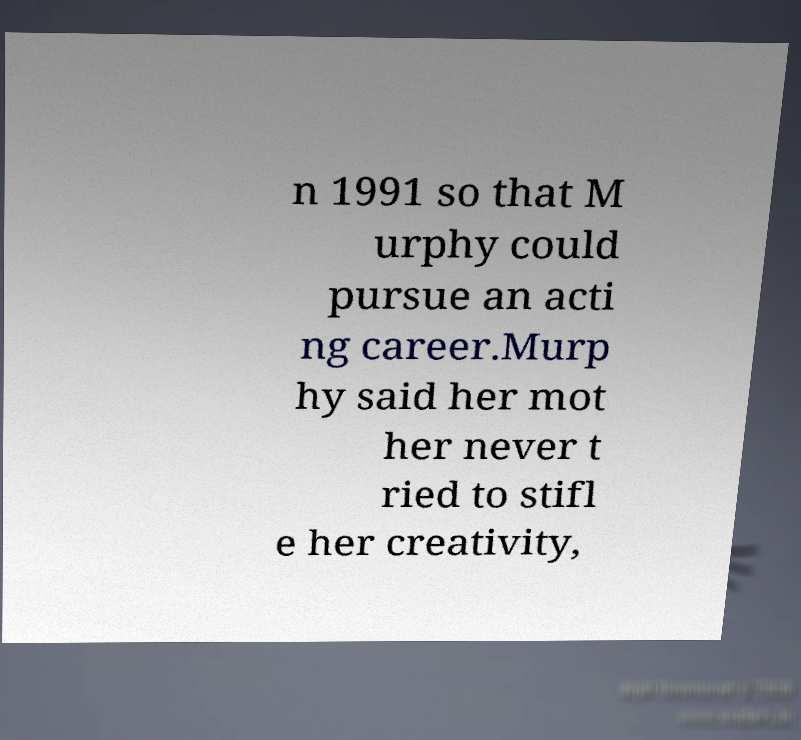Please identify and transcribe the text found in this image. n 1991 so that M urphy could pursue an acti ng career.Murp hy said her mot her never t ried to stifl e her creativity, 